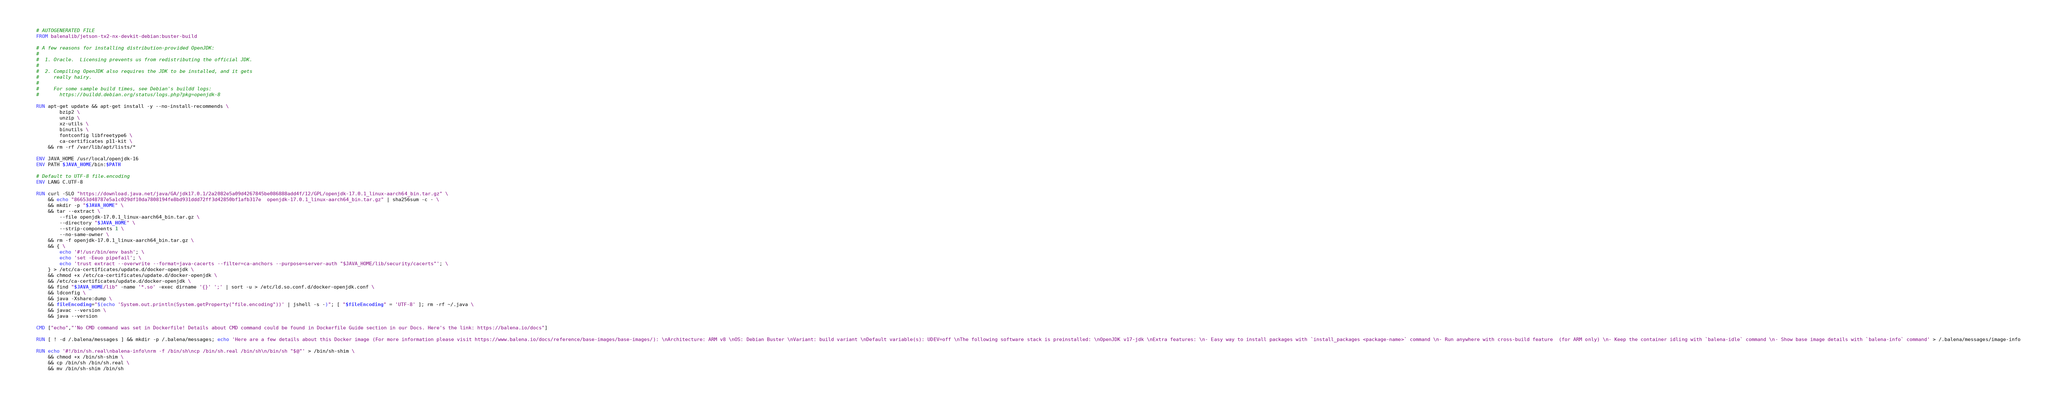<code> <loc_0><loc_0><loc_500><loc_500><_Dockerfile_># AUTOGENERATED FILE
FROM balenalib/jetson-tx2-nx-devkit-debian:buster-build

# A few reasons for installing distribution-provided OpenJDK:
#
#  1. Oracle.  Licensing prevents us from redistributing the official JDK.
#
#  2. Compiling OpenJDK also requires the JDK to be installed, and it gets
#     really hairy.
#
#     For some sample build times, see Debian's buildd logs:
#       https://buildd.debian.org/status/logs.php?pkg=openjdk-8

RUN apt-get update && apt-get install -y --no-install-recommends \
		bzip2 \
		unzip \
		xz-utils \
		binutils \
		fontconfig libfreetype6 \
		ca-certificates p11-kit \
	&& rm -rf /var/lib/apt/lists/*

ENV JAVA_HOME /usr/local/openjdk-16
ENV PATH $JAVA_HOME/bin:$PATH

# Default to UTF-8 file.encoding
ENV LANG C.UTF-8

RUN curl -SLO "https://download.java.net/java/GA/jdk17.0.1/2a2082e5a09d4267845be086888add4f/12/GPL/openjdk-17.0.1_linux-aarch64_bin.tar.gz" \
	&& echo "86653d48787e5a1c029df10da7808194fe8bd931ddd72ff3d42850bf1afb317e  openjdk-17.0.1_linux-aarch64_bin.tar.gz" | sha256sum -c - \
	&& mkdir -p "$JAVA_HOME" \
	&& tar --extract \
		--file openjdk-17.0.1_linux-aarch64_bin.tar.gz \
		--directory "$JAVA_HOME" \
		--strip-components 1 \
		--no-same-owner \
	&& rm -f openjdk-17.0.1_linux-aarch64_bin.tar.gz \
	&& { \
		echo '#!/usr/bin/env bash'; \
		echo 'set -Eeuo pipefail'; \
		echo 'trust extract --overwrite --format=java-cacerts --filter=ca-anchors --purpose=server-auth "$JAVA_HOME/lib/security/cacerts"'; \
	} > /etc/ca-certificates/update.d/docker-openjdk \
	&& chmod +x /etc/ca-certificates/update.d/docker-openjdk \
	&& /etc/ca-certificates/update.d/docker-openjdk \
	&& find "$JAVA_HOME/lib" -name '*.so' -exec dirname '{}' ';' | sort -u > /etc/ld.so.conf.d/docker-openjdk.conf \
	&& ldconfig \
	&& java -Xshare:dump \
	&& fileEncoding="$(echo 'System.out.println(System.getProperty("file.encoding"))' | jshell -s -)"; [ "$fileEncoding" = 'UTF-8' ]; rm -rf ~/.java \
	&& javac --version \
	&& java --version

CMD ["echo","'No CMD command was set in Dockerfile! Details about CMD command could be found in Dockerfile Guide section in our Docs. Here's the link: https://balena.io/docs"]

RUN [ ! -d /.balena/messages ] && mkdir -p /.balena/messages; echo 'Here are a few details about this Docker image (For more information please visit https://www.balena.io/docs/reference/base-images/base-images/): \nArchitecture: ARM v8 \nOS: Debian Buster \nVariant: build variant \nDefault variable(s): UDEV=off \nThe following software stack is preinstalled: \nOpenJDK v17-jdk \nExtra features: \n- Easy way to install packages with `install_packages <package-name>` command \n- Run anywhere with cross-build feature  (for ARM only) \n- Keep the container idling with `balena-idle` command \n- Show base image details with `balena-info` command' > /.balena/messages/image-info

RUN echo '#!/bin/sh.real\nbalena-info\nrm -f /bin/sh\ncp /bin/sh.real /bin/sh\n/bin/sh "$@"' > /bin/sh-shim \
	&& chmod +x /bin/sh-shim \
	&& cp /bin/sh /bin/sh.real \
	&& mv /bin/sh-shim /bin/sh</code> 